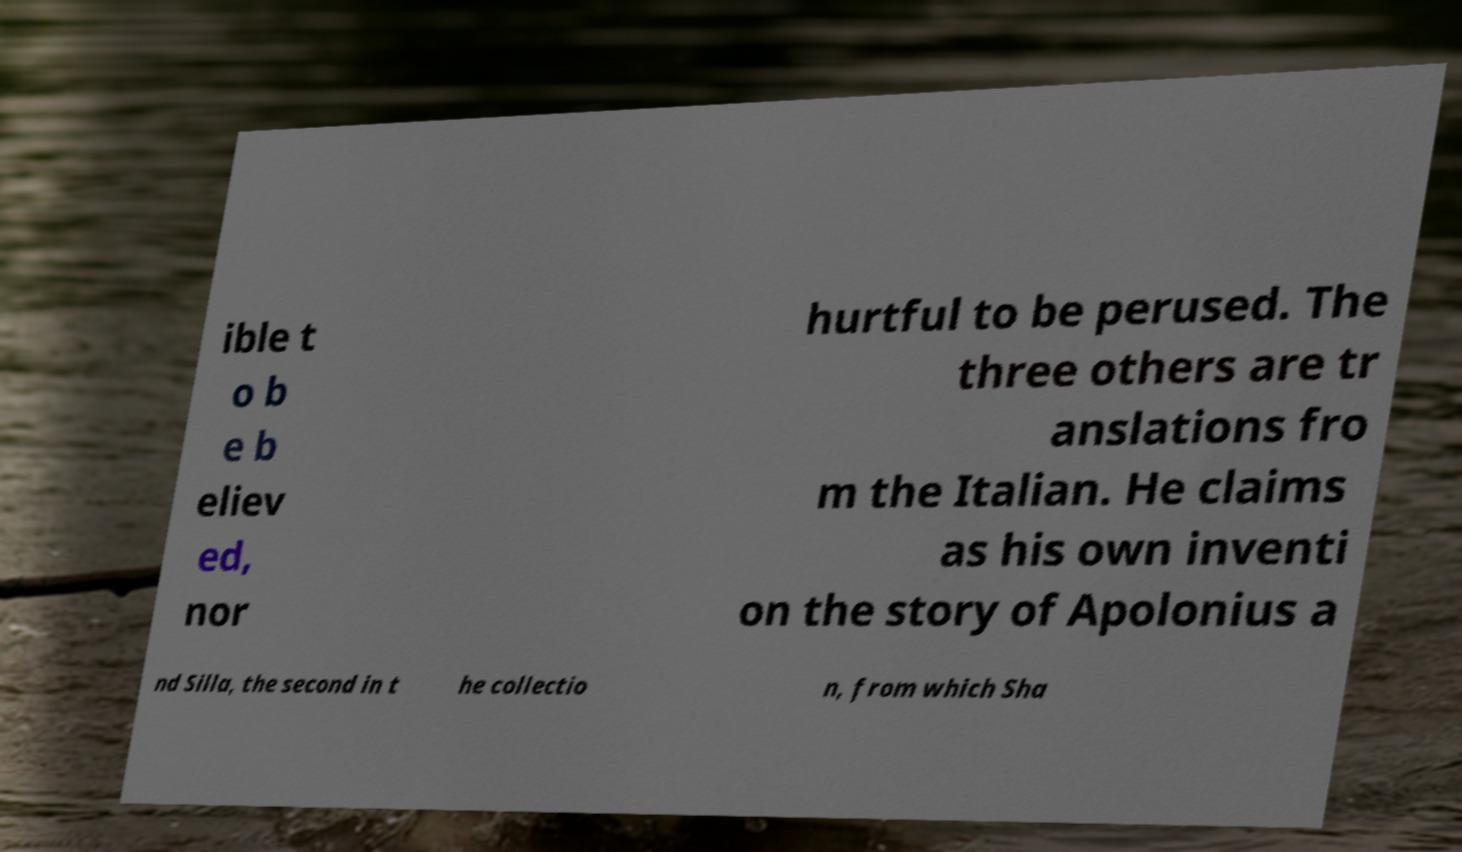Please identify and transcribe the text found in this image. ible t o b e b eliev ed, nor hurtful to be perused. The three others are tr anslations fro m the Italian. He claims as his own inventi on the story of Apolonius a nd Silla, the second in t he collectio n, from which Sha 